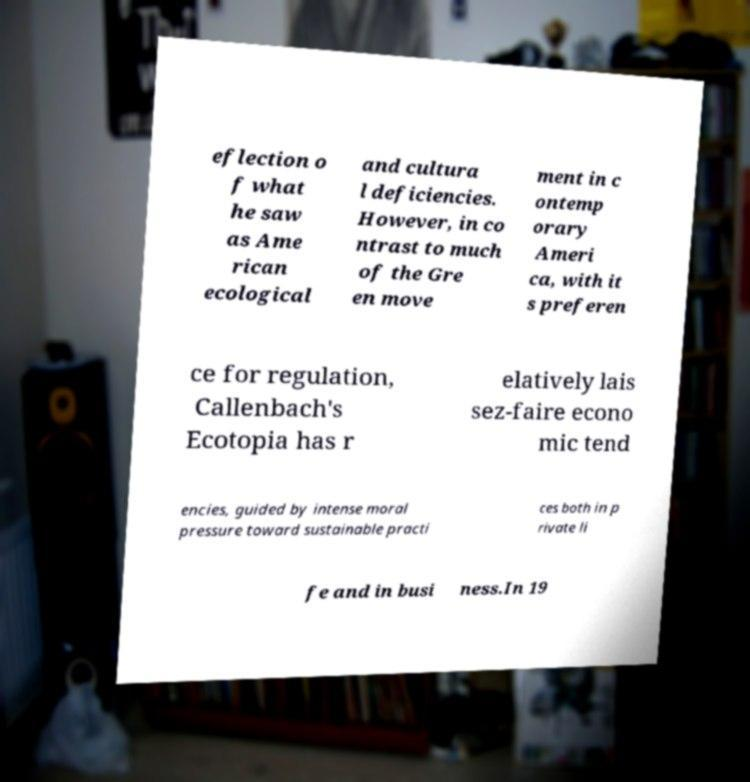Please identify and transcribe the text found in this image. eflection o f what he saw as Ame rican ecological and cultura l deficiencies. However, in co ntrast to much of the Gre en move ment in c ontemp orary Ameri ca, with it s preferen ce for regulation, Callenbach's Ecotopia has r elatively lais sez-faire econo mic tend encies, guided by intense moral pressure toward sustainable practi ces both in p rivate li fe and in busi ness.In 19 